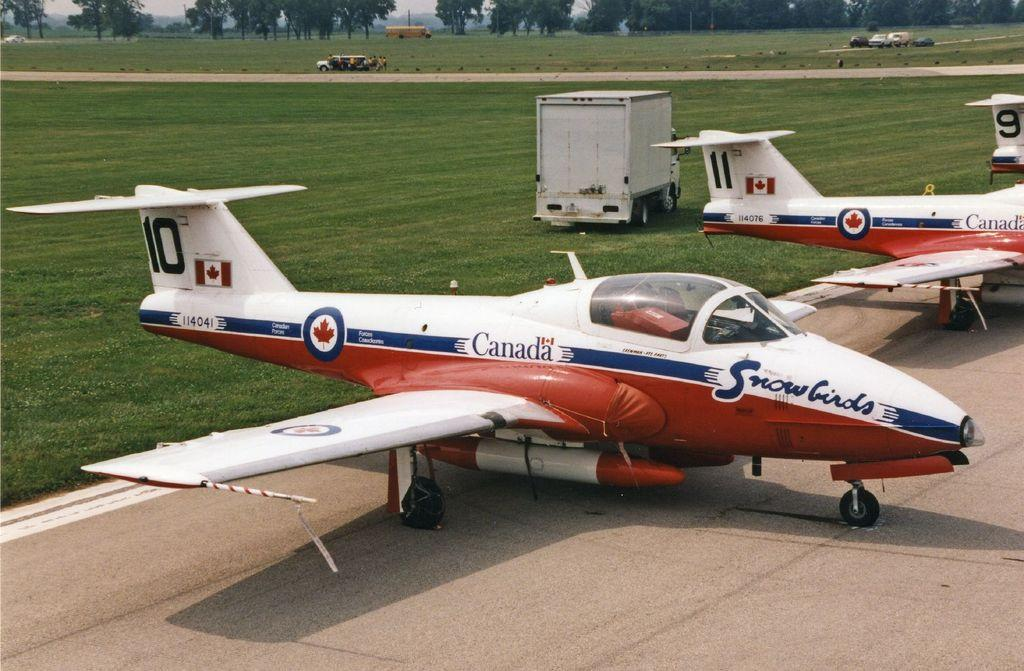<image>
Render a clear and concise summary of the photo. A red, white, and blue plane with the words Canada and Snowbirds on it. 